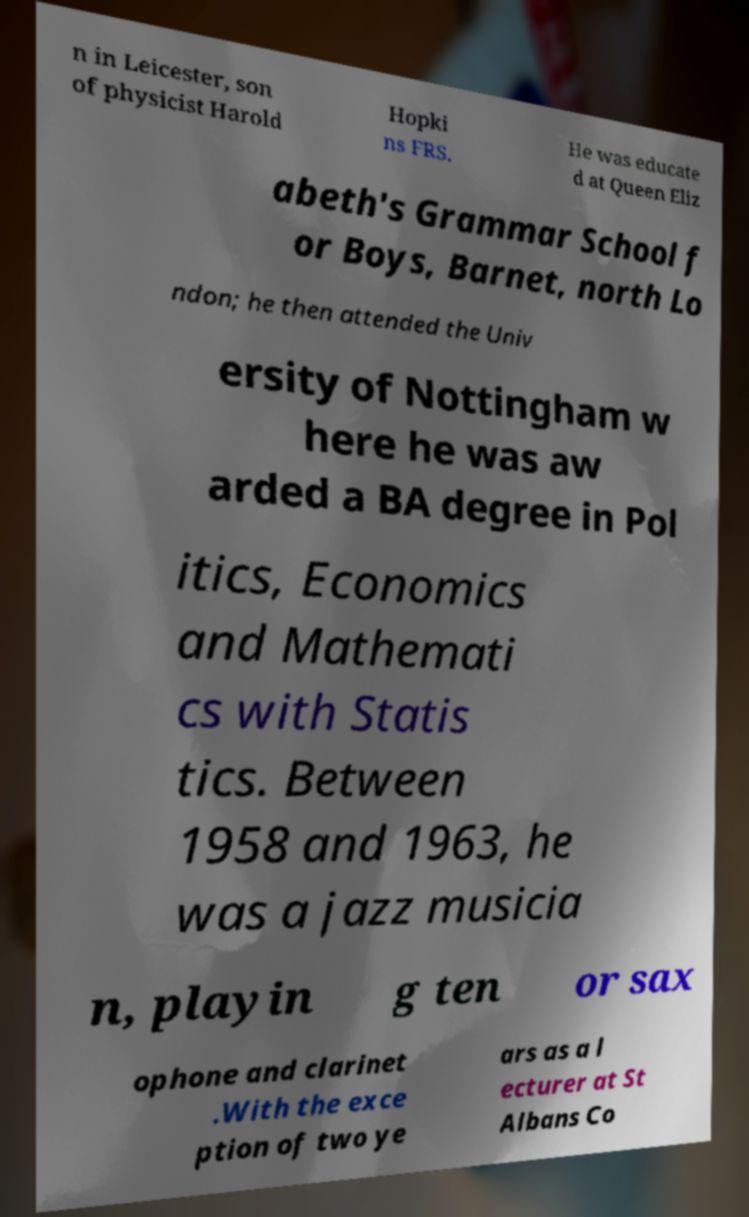There's text embedded in this image that I need extracted. Can you transcribe it verbatim? n in Leicester, son of physicist Harold Hopki ns FRS. He was educate d at Queen Eliz abeth's Grammar School f or Boys, Barnet, north Lo ndon; he then attended the Univ ersity of Nottingham w here he was aw arded a BA degree in Pol itics, Economics and Mathemati cs with Statis tics. Between 1958 and 1963, he was a jazz musicia n, playin g ten or sax ophone and clarinet .With the exce ption of two ye ars as a l ecturer at St Albans Co 